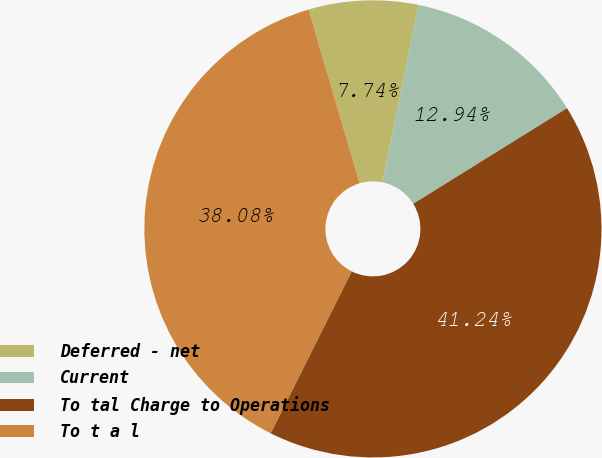Convert chart to OTSL. <chart><loc_0><loc_0><loc_500><loc_500><pie_chart><fcel>Deferred - net<fcel>Current<fcel>To tal Charge to Operations<fcel>To t a l<nl><fcel>7.74%<fcel>12.94%<fcel>41.24%<fcel>38.08%<nl></chart> 